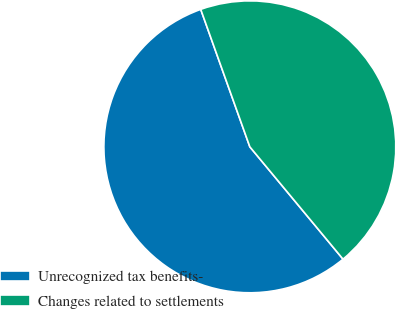Convert chart to OTSL. <chart><loc_0><loc_0><loc_500><loc_500><pie_chart><fcel>Unrecognized tax benefits-<fcel>Changes related to settlements<nl><fcel>55.56%<fcel>44.44%<nl></chart> 